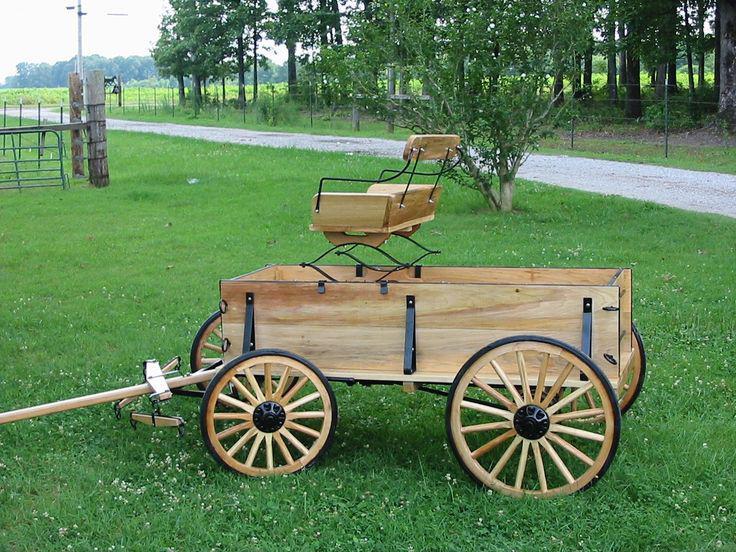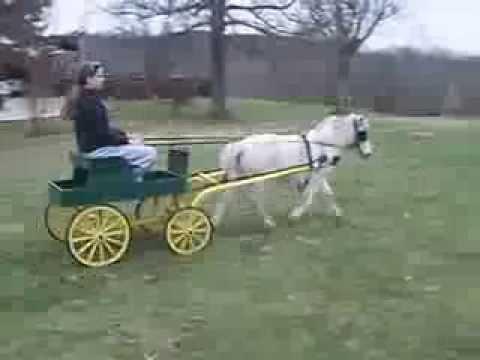The first image is the image on the left, the second image is the image on the right. Examine the images to the left and right. Is the description "There is a human riding a carriage." accurate? Answer yes or no. Yes. 